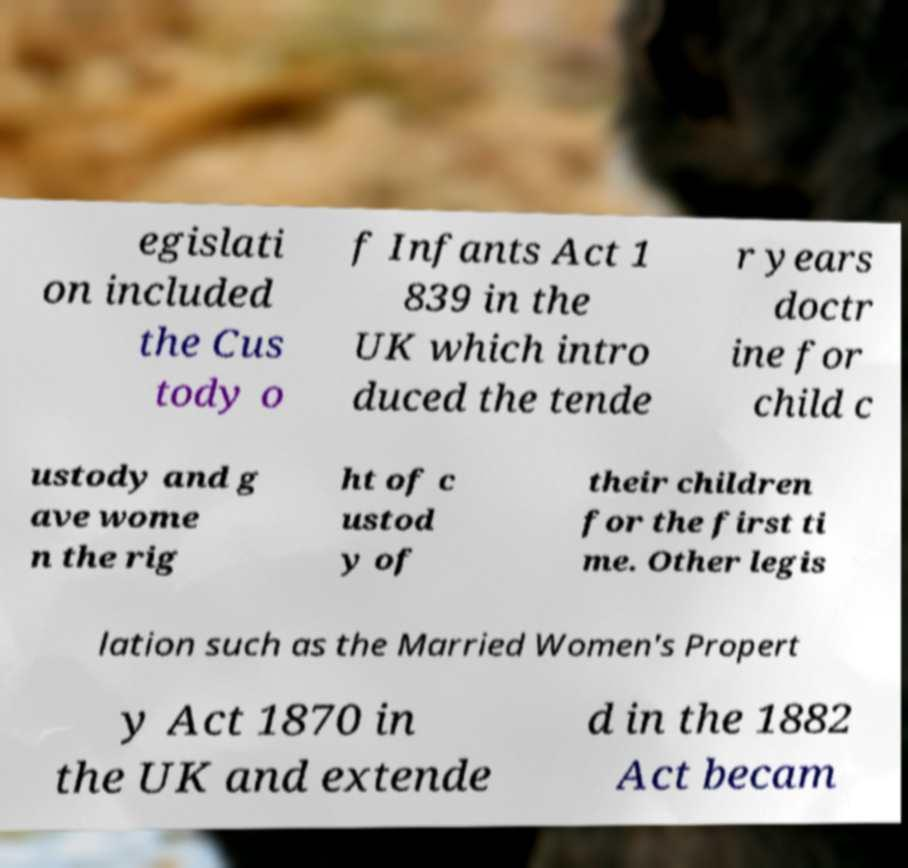Please identify and transcribe the text found in this image. egislati on included the Cus tody o f Infants Act 1 839 in the UK which intro duced the tende r years doctr ine for child c ustody and g ave wome n the rig ht of c ustod y of their children for the first ti me. Other legis lation such as the Married Women's Propert y Act 1870 in the UK and extende d in the 1882 Act becam 